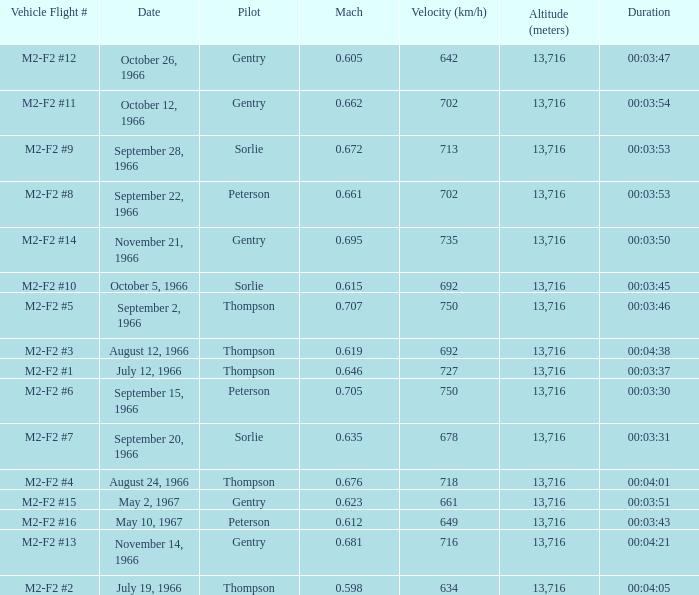What Date has a Mach of 0.662? October 12, 1966. 